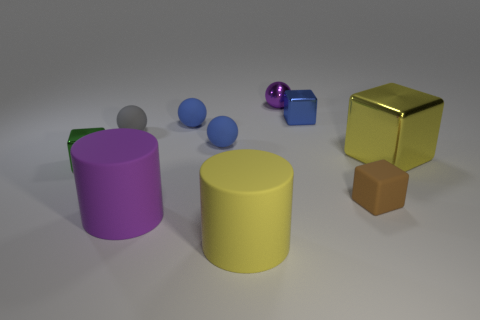Subtract 1 spheres. How many spheres are left? 3 Subtract all cubes. How many objects are left? 6 Add 4 brown rubber cubes. How many brown rubber cubes exist? 5 Subtract 0 gray blocks. How many objects are left? 10 Subtract all red spheres. Subtract all yellow objects. How many objects are left? 8 Add 2 blue metallic things. How many blue metallic things are left? 3 